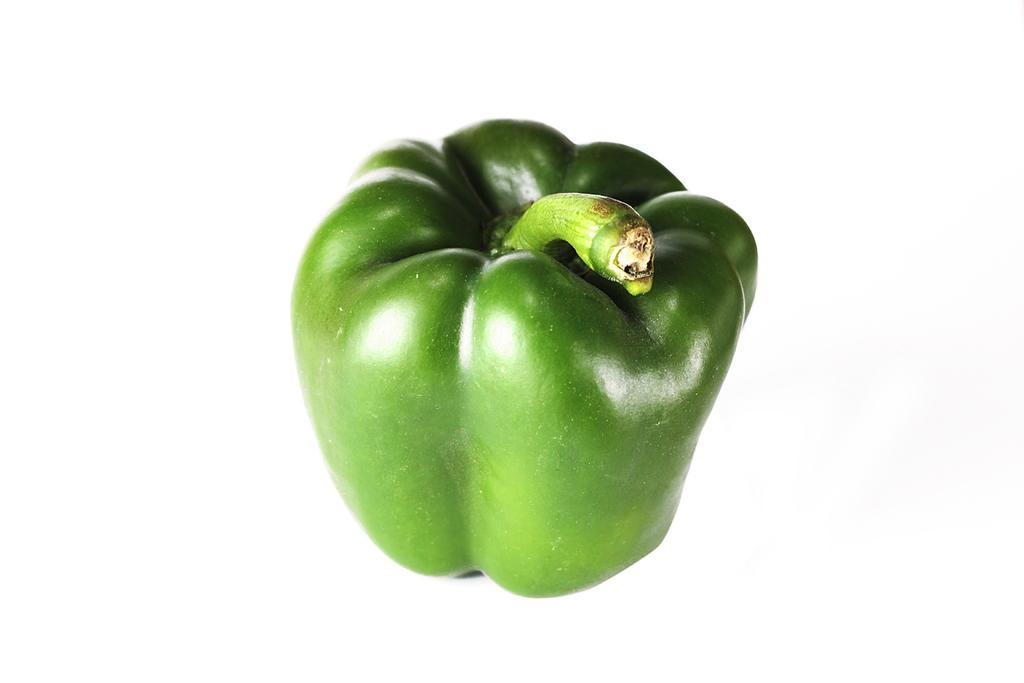What type of vegetable is present in the image? There is a capsicum in the image. How does the rat interact with the capsicum in the image? There is no rat present in the image, so it is not possible to answer that question. 